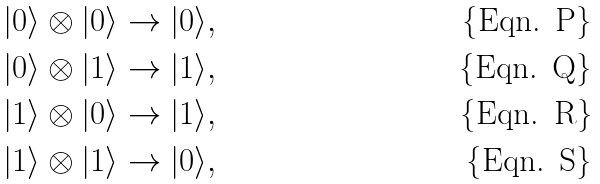<formula> <loc_0><loc_0><loc_500><loc_500>| 0 \rangle \otimes | 0 \rangle & \rightarrow | 0 \rangle , \\ | 0 \rangle \otimes | 1 \rangle & \rightarrow | 1 \rangle , \\ | 1 \rangle \otimes | 0 \rangle & \rightarrow | 1 \rangle , \\ | 1 \rangle \otimes | 1 \rangle & \rightarrow | 0 \rangle ,</formula> 